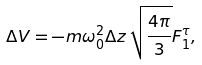Convert formula to latex. <formula><loc_0><loc_0><loc_500><loc_500>\Delta V = - m \omega _ { 0 } ^ { 2 } \Delta z \, \sqrt { \frac { 4 \pi } { 3 } } F _ { 1 } ^ { \tau } ,</formula> 